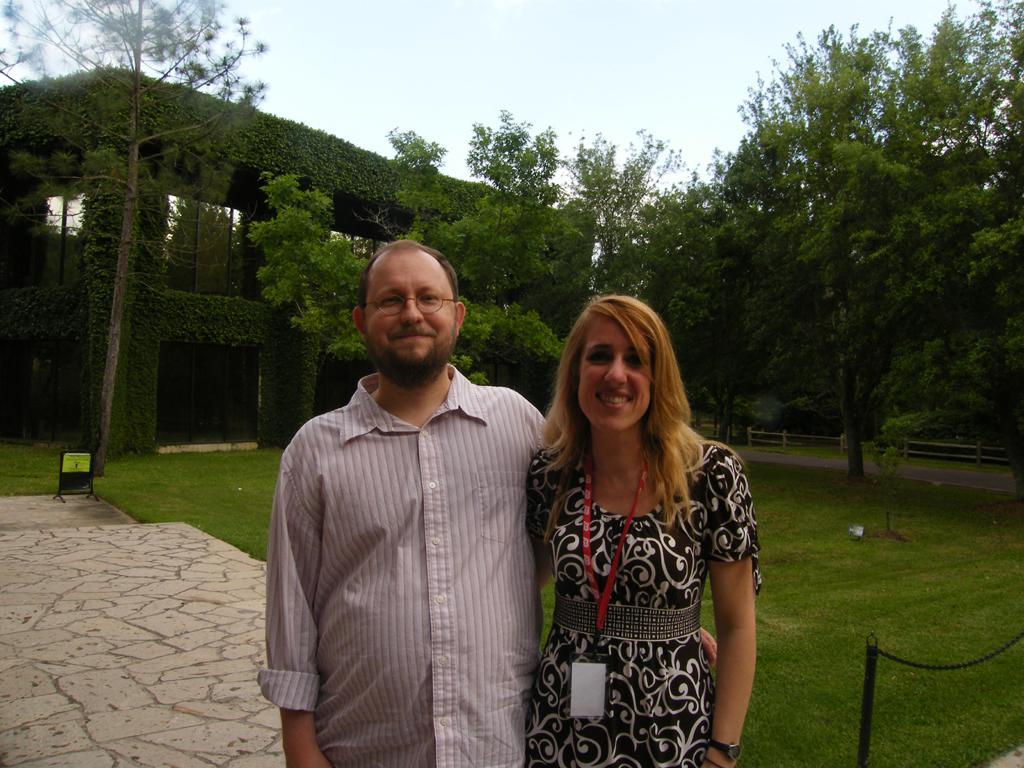Describe this image in one or two sentences. In this picture we can observe a couple standing and smiling. One of them was a man wearing spectacles and the other was a woman wearing black color dress and red color tag in her neck. Behind them there is a lawn. We can observe a building. There are some trees. In the background there is a sky. 